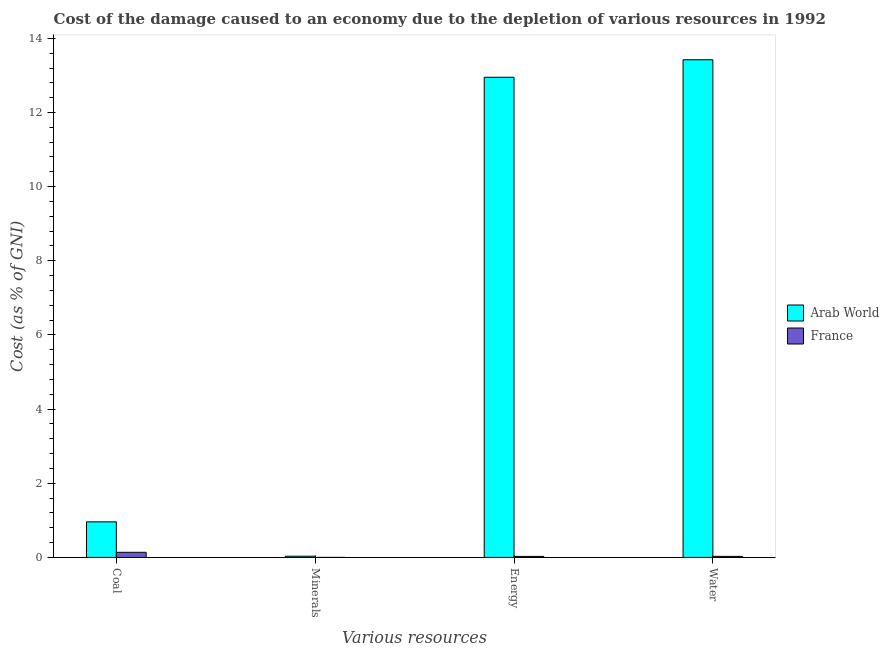How many groups of bars are there?
Your answer should be compact. 4. Are the number of bars per tick equal to the number of legend labels?
Your response must be concise. Yes. Are the number of bars on each tick of the X-axis equal?
Ensure brevity in your answer.  Yes. How many bars are there on the 2nd tick from the left?
Your answer should be compact. 2. What is the label of the 3rd group of bars from the left?
Ensure brevity in your answer.  Energy. What is the cost of damage due to depletion of water in France?
Give a very brief answer. 0.03. Across all countries, what is the maximum cost of damage due to depletion of energy?
Your answer should be compact. 12.95. Across all countries, what is the minimum cost of damage due to depletion of coal?
Ensure brevity in your answer.  0.14. In which country was the cost of damage due to depletion of energy maximum?
Your answer should be compact. Arab World. What is the total cost of damage due to depletion of coal in the graph?
Give a very brief answer. 1.1. What is the difference between the cost of damage due to depletion of minerals in France and that in Arab World?
Your answer should be very brief. -0.03. What is the difference between the cost of damage due to depletion of water in France and the cost of damage due to depletion of energy in Arab World?
Your answer should be compact. -12.92. What is the average cost of damage due to depletion of energy per country?
Give a very brief answer. 6.49. What is the difference between the cost of damage due to depletion of minerals and cost of damage due to depletion of coal in Arab World?
Keep it short and to the point. -0.93. In how many countries, is the cost of damage due to depletion of coal greater than 6.8 %?
Keep it short and to the point. 0. What is the ratio of the cost of damage due to depletion of energy in France to that in Arab World?
Your answer should be compact. 0. Is the cost of damage due to depletion of energy in France less than that in Arab World?
Your answer should be very brief. Yes. Is the difference between the cost of damage due to depletion of coal in France and Arab World greater than the difference between the cost of damage due to depletion of minerals in France and Arab World?
Your response must be concise. No. What is the difference between the highest and the second highest cost of damage due to depletion of water?
Provide a succinct answer. 13.39. What is the difference between the highest and the lowest cost of damage due to depletion of water?
Your answer should be compact. 13.39. Is it the case that in every country, the sum of the cost of damage due to depletion of minerals and cost of damage due to depletion of energy is greater than the sum of cost of damage due to depletion of coal and cost of damage due to depletion of water?
Provide a short and direct response. No. What does the 2nd bar from the right in Water represents?
Give a very brief answer. Arab World. How many bars are there?
Give a very brief answer. 8. How many countries are there in the graph?
Offer a terse response. 2. What is the difference between two consecutive major ticks on the Y-axis?
Keep it short and to the point. 2. Are the values on the major ticks of Y-axis written in scientific E-notation?
Provide a succinct answer. No. Where does the legend appear in the graph?
Provide a succinct answer. Center right. What is the title of the graph?
Offer a terse response. Cost of the damage caused to an economy due to the depletion of various resources in 1992 . What is the label or title of the X-axis?
Offer a very short reply. Various resources. What is the label or title of the Y-axis?
Provide a succinct answer. Cost (as % of GNI). What is the Cost (as % of GNI) of Arab World in Coal?
Keep it short and to the point. 0.96. What is the Cost (as % of GNI) of France in Coal?
Give a very brief answer. 0.14. What is the Cost (as % of GNI) in Arab World in Minerals?
Your answer should be very brief. 0.03. What is the Cost (as % of GNI) of France in Minerals?
Your answer should be very brief. 0. What is the Cost (as % of GNI) in Arab World in Energy?
Make the answer very short. 12.95. What is the Cost (as % of GNI) in France in Energy?
Offer a terse response. 0.03. What is the Cost (as % of GNI) of Arab World in Water?
Give a very brief answer. 13.42. What is the Cost (as % of GNI) of France in Water?
Give a very brief answer. 0.03. Across all Various resources, what is the maximum Cost (as % of GNI) in Arab World?
Offer a very short reply. 13.42. Across all Various resources, what is the maximum Cost (as % of GNI) in France?
Make the answer very short. 0.14. Across all Various resources, what is the minimum Cost (as % of GNI) in Arab World?
Your response must be concise. 0.03. Across all Various resources, what is the minimum Cost (as % of GNI) in France?
Your answer should be very brief. 0. What is the total Cost (as % of GNI) of Arab World in the graph?
Your answer should be very brief. 27.36. What is the total Cost (as % of GNI) in France in the graph?
Keep it short and to the point. 0.19. What is the difference between the Cost (as % of GNI) of Arab World in Coal and that in Minerals?
Offer a very short reply. 0.93. What is the difference between the Cost (as % of GNI) of France in Coal and that in Minerals?
Your answer should be very brief. 0.14. What is the difference between the Cost (as % of GNI) in Arab World in Coal and that in Energy?
Your answer should be very brief. -11.99. What is the difference between the Cost (as % of GNI) of France in Coal and that in Energy?
Your response must be concise. 0.11. What is the difference between the Cost (as % of GNI) of Arab World in Coal and that in Water?
Your response must be concise. -12.46. What is the difference between the Cost (as % of GNI) of France in Coal and that in Water?
Your answer should be very brief. 0.11. What is the difference between the Cost (as % of GNI) of Arab World in Minerals and that in Energy?
Offer a terse response. -12.92. What is the difference between the Cost (as % of GNI) of France in Minerals and that in Energy?
Provide a succinct answer. -0.03. What is the difference between the Cost (as % of GNI) in Arab World in Minerals and that in Water?
Make the answer very short. -13.39. What is the difference between the Cost (as % of GNI) of France in Minerals and that in Water?
Offer a very short reply. -0.03. What is the difference between the Cost (as % of GNI) in Arab World in Energy and that in Water?
Make the answer very short. -0.47. What is the difference between the Cost (as % of GNI) in France in Energy and that in Water?
Give a very brief answer. -0. What is the difference between the Cost (as % of GNI) in Arab World in Coal and the Cost (as % of GNI) in France in Minerals?
Your answer should be very brief. 0.96. What is the difference between the Cost (as % of GNI) in Arab World in Coal and the Cost (as % of GNI) in France in Energy?
Keep it short and to the point. 0.93. What is the difference between the Cost (as % of GNI) in Arab World in Coal and the Cost (as % of GNI) in France in Water?
Your answer should be compact. 0.93. What is the difference between the Cost (as % of GNI) in Arab World in Minerals and the Cost (as % of GNI) in France in Energy?
Your answer should be compact. 0. What is the difference between the Cost (as % of GNI) in Arab World in Minerals and the Cost (as % of GNI) in France in Water?
Make the answer very short. 0. What is the difference between the Cost (as % of GNI) in Arab World in Energy and the Cost (as % of GNI) in France in Water?
Your answer should be very brief. 12.92. What is the average Cost (as % of GNI) in Arab World per Various resources?
Keep it short and to the point. 6.84. What is the average Cost (as % of GNI) in France per Various resources?
Offer a very short reply. 0.05. What is the difference between the Cost (as % of GNI) in Arab World and Cost (as % of GNI) in France in Coal?
Provide a succinct answer. 0.82. What is the difference between the Cost (as % of GNI) in Arab World and Cost (as % of GNI) in France in Minerals?
Your answer should be very brief. 0.03. What is the difference between the Cost (as % of GNI) of Arab World and Cost (as % of GNI) of France in Energy?
Offer a very short reply. 12.92. What is the difference between the Cost (as % of GNI) in Arab World and Cost (as % of GNI) in France in Water?
Your answer should be compact. 13.39. What is the ratio of the Cost (as % of GNI) of Arab World in Coal to that in Minerals?
Your answer should be compact. 29.22. What is the ratio of the Cost (as % of GNI) of France in Coal to that in Minerals?
Provide a short and direct response. 947.01. What is the ratio of the Cost (as % of GNI) in Arab World in Coal to that in Energy?
Make the answer very short. 0.07. What is the ratio of the Cost (as % of GNI) of France in Coal to that in Energy?
Make the answer very short. 4.95. What is the ratio of the Cost (as % of GNI) in Arab World in Coal to that in Water?
Offer a very short reply. 0.07. What is the ratio of the Cost (as % of GNI) in France in Coal to that in Water?
Your answer should be compact. 4.92. What is the ratio of the Cost (as % of GNI) in Arab World in Minerals to that in Energy?
Your answer should be very brief. 0. What is the ratio of the Cost (as % of GNI) of France in Minerals to that in Energy?
Offer a very short reply. 0.01. What is the ratio of the Cost (as % of GNI) in Arab World in Minerals to that in Water?
Your answer should be very brief. 0. What is the ratio of the Cost (as % of GNI) of France in Minerals to that in Water?
Offer a very short reply. 0.01. What is the ratio of the Cost (as % of GNI) of Arab World in Energy to that in Water?
Provide a short and direct response. 0.96. What is the ratio of the Cost (as % of GNI) in France in Energy to that in Water?
Provide a succinct answer. 0.99. What is the difference between the highest and the second highest Cost (as % of GNI) of Arab World?
Keep it short and to the point. 0.47. What is the difference between the highest and the second highest Cost (as % of GNI) in France?
Provide a succinct answer. 0.11. What is the difference between the highest and the lowest Cost (as % of GNI) of Arab World?
Your response must be concise. 13.39. What is the difference between the highest and the lowest Cost (as % of GNI) in France?
Keep it short and to the point. 0.14. 